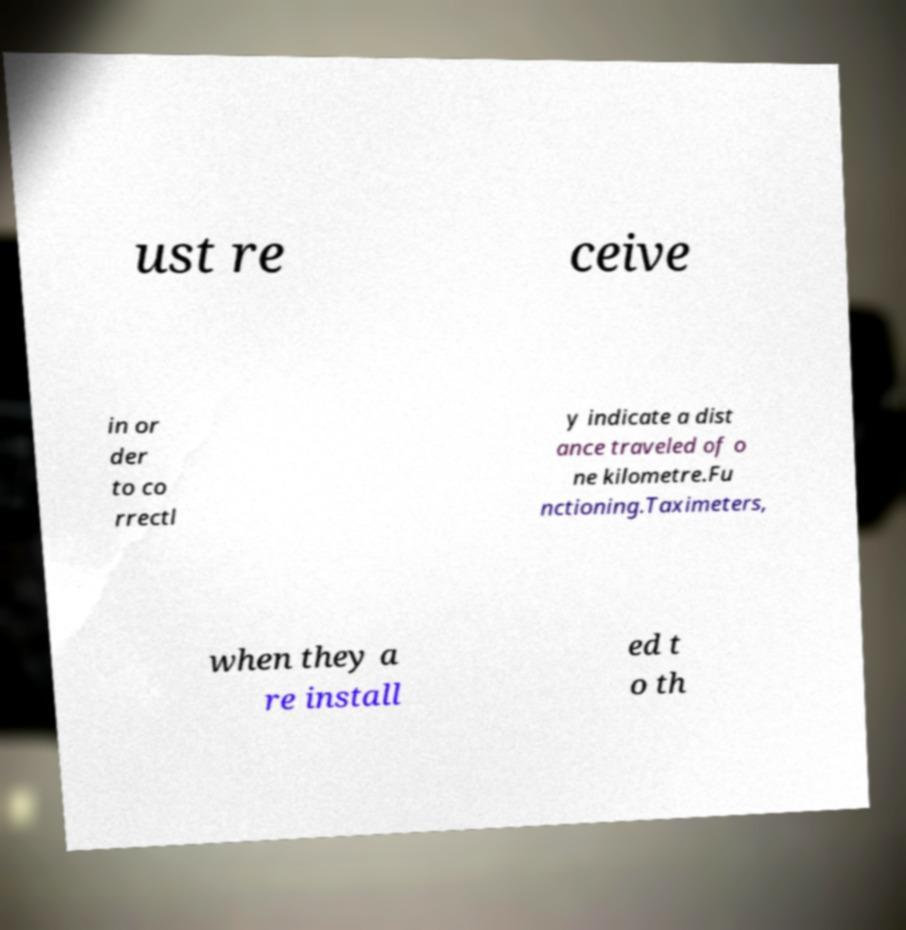I need the written content from this picture converted into text. Can you do that? ust re ceive in or der to co rrectl y indicate a dist ance traveled of o ne kilometre.Fu nctioning.Taximeters, when they a re install ed t o th 